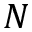<formula> <loc_0><loc_0><loc_500><loc_500>N</formula> 